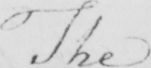What does this handwritten line say? The 